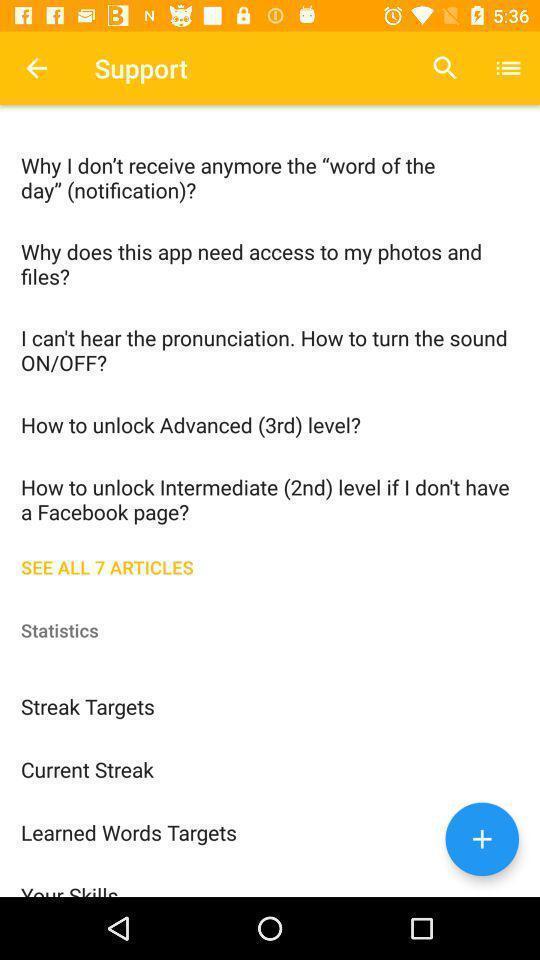What can you discern from this picture? Support tab in the application with some questions. 